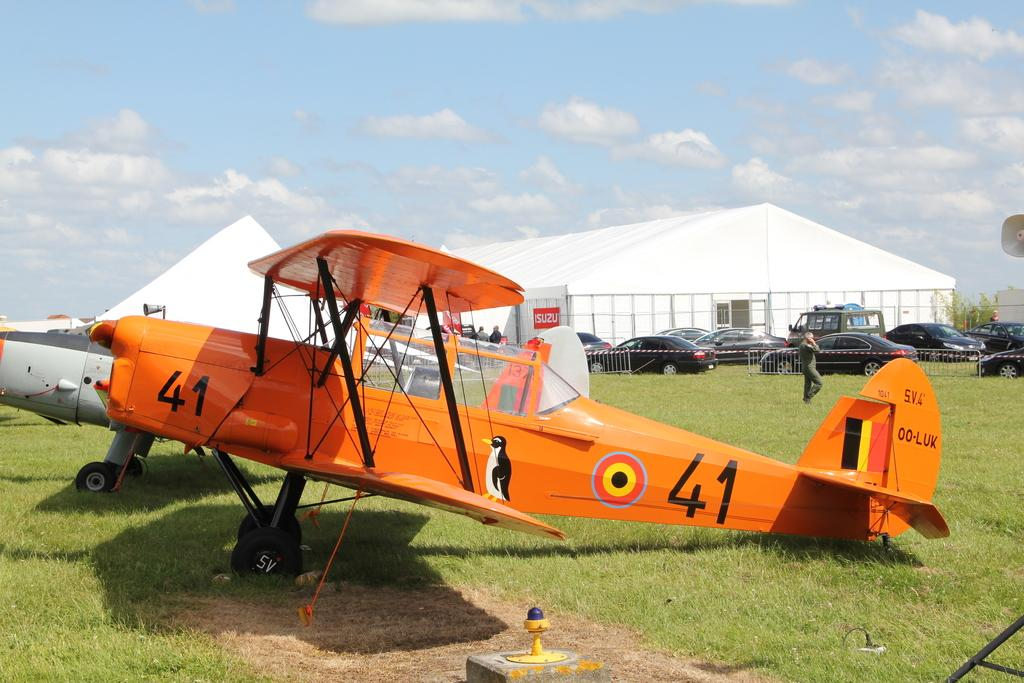What is the main subject of the image? The main subject of the image is a flying jet. What else can be seen in the image besides the jet? There are vehicles, a person walking, grass, a tent, a fence, and a board in the image. Can you describe the person in the image? The person is walking and wearing clothes. What is the condition of the sky in the image? The sky is cloudy in the image. How many cacti are present in the image? There are no cacti present in the image. What type of car is parked near the tent in the image? There is no car present in the image. 